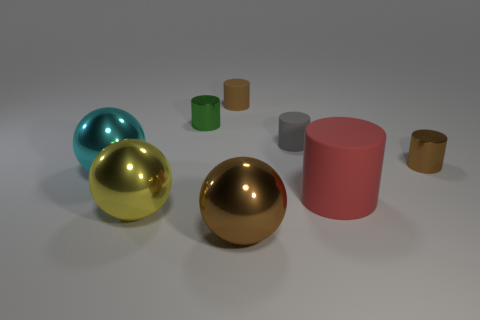Subtract all red cylinders. How many cylinders are left? 4 Subtract all red cylinders. How many cylinders are left? 4 Subtract all blue cylinders. Subtract all yellow blocks. How many cylinders are left? 5 Add 2 big cyan metal cylinders. How many objects exist? 10 Subtract all cylinders. How many objects are left? 3 Subtract 0 cyan cylinders. How many objects are left? 8 Subtract all shiny cylinders. Subtract all large cyan metallic spheres. How many objects are left? 5 Add 7 green shiny cylinders. How many green shiny cylinders are left? 8 Add 7 large yellow metallic blocks. How many large yellow metallic blocks exist? 7 